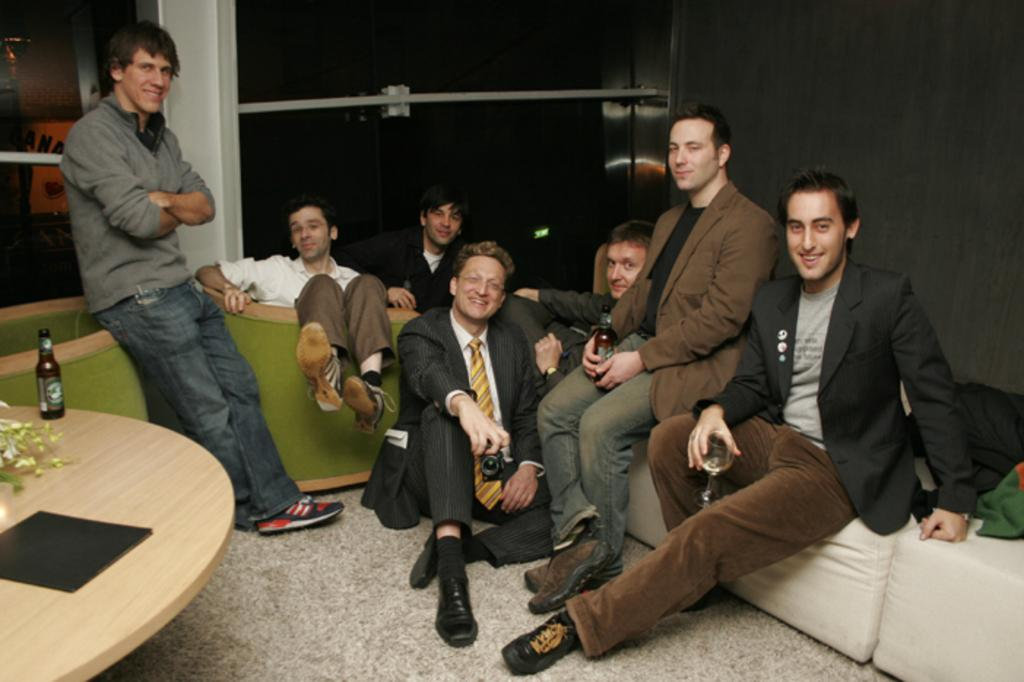What are the people in the image doing? The persons in the image are sitting. Is there anyone standing in the image? Yes, there is a person standing in the image. What can be seen on the floor in the image? The floor is visible in the image. What piece of furniture is present in the image? There is a table in the image. What object is on the table? There is a bottle on the table. What can be seen in the background of the image? There is a window and a wall in the background of the image. What type of key is used to unlock the ship in the image? There is no ship or key present in the image. How does the memory of the event affect the people in the image? There is no indication of any event or memory in the image. 